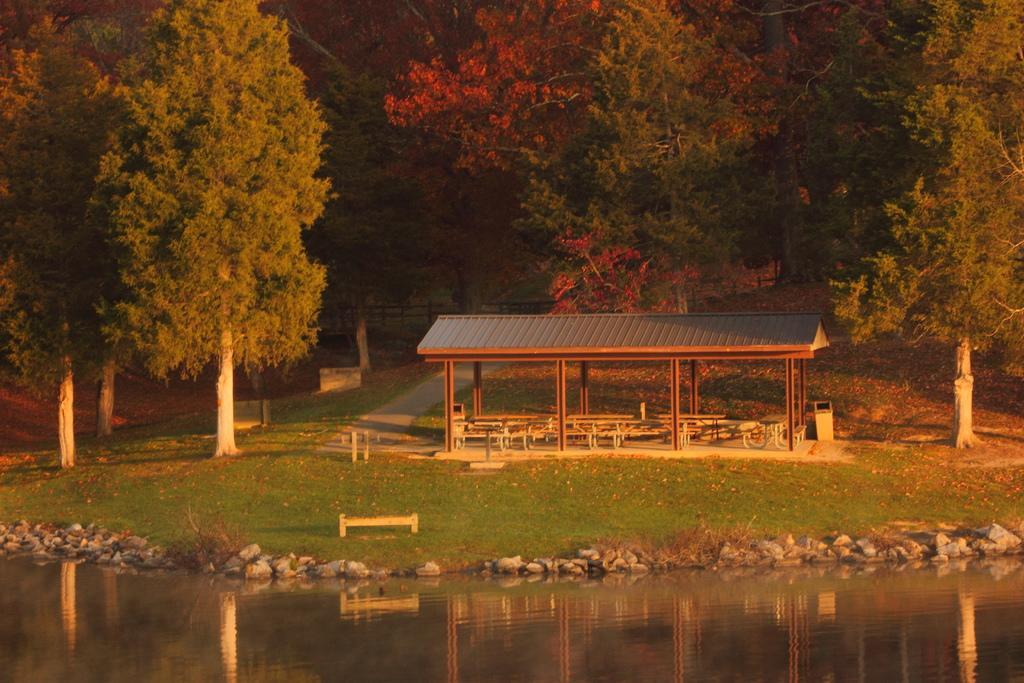In one or two sentences, can you explain what this image depicts? This image consists of many trees. At the bottom, there is water. In the middle, there is a small shed along with the chairs. And there is green grass on the ground. We can see many rocks in this image. 